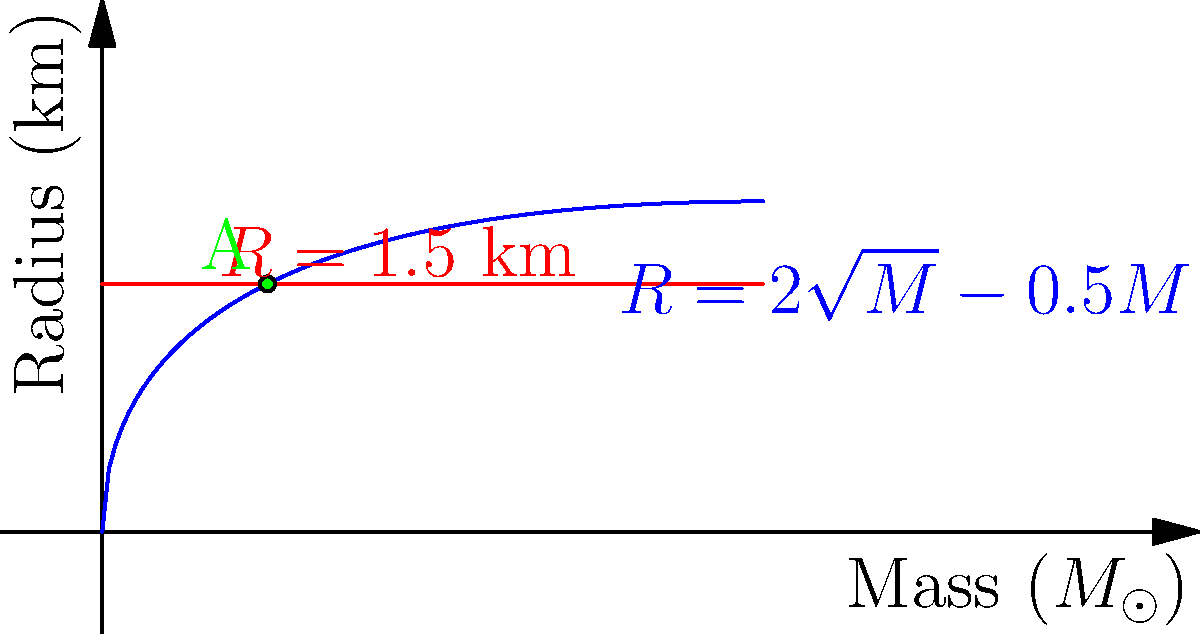The graph shows the mass-radius relationship for a hypothetical neutron star (blue curve) and a constant radius line (red line). The intersection point A represents a stable configuration. Given that the radius at point A is 1.5 km, determine the mass of the neutron star at this point in solar masses ($M_{\odot}$). Round your answer to two decimal places. To solve this problem, we'll follow these steps:

1) The mass-radius relationship for the neutron star is given by:
   $$R = 2\sqrt{M} - 0.5M$$

2) At point A, we know that $R = 1.5$ km. Let's substitute this into the equation:
   $$1.5 = 2\sqrt{M} - 0.5M$$

3) Rearrange the equation:
   $$2\sqrt{M} = 1.5 + 0.5M$$
   $$2\sqrt{M} = 1.5 + 0.5M$$

4) Square both sides:
   $$4M = (1.5 + 0.5M)^2$$
   $$4M = 2.25 + 1.5M + 0.25M^2$$

5) Rearrange to standard quadratic form:
   $$0.25M^2 - 2.5M + 2.25 = 0$$

6) Solve using the quadratic formula: $M = \frac{-b \pm \sqrt{b^2 - 4ac}}{2a}$
   Where $a = 0.25$, $b = -2.5$, and $c = 2.25$

   $$M = \frac{2.5 \pm \sqrt{6.25 - 2.25}}{0.5}$$
   $$M = \frac{2.5 \pm 2}{0.5}$$

7) This gives us two solutions: $M = 9$ or $M = 1$

8) Looking at the graph, we can see that the intersection point A corresponds to the smaller mass value.

Therefore, the mass of the neutron star at point A is 1 $M_{\odot}$.
Answer: 1.00 $M_{\odot}$ 